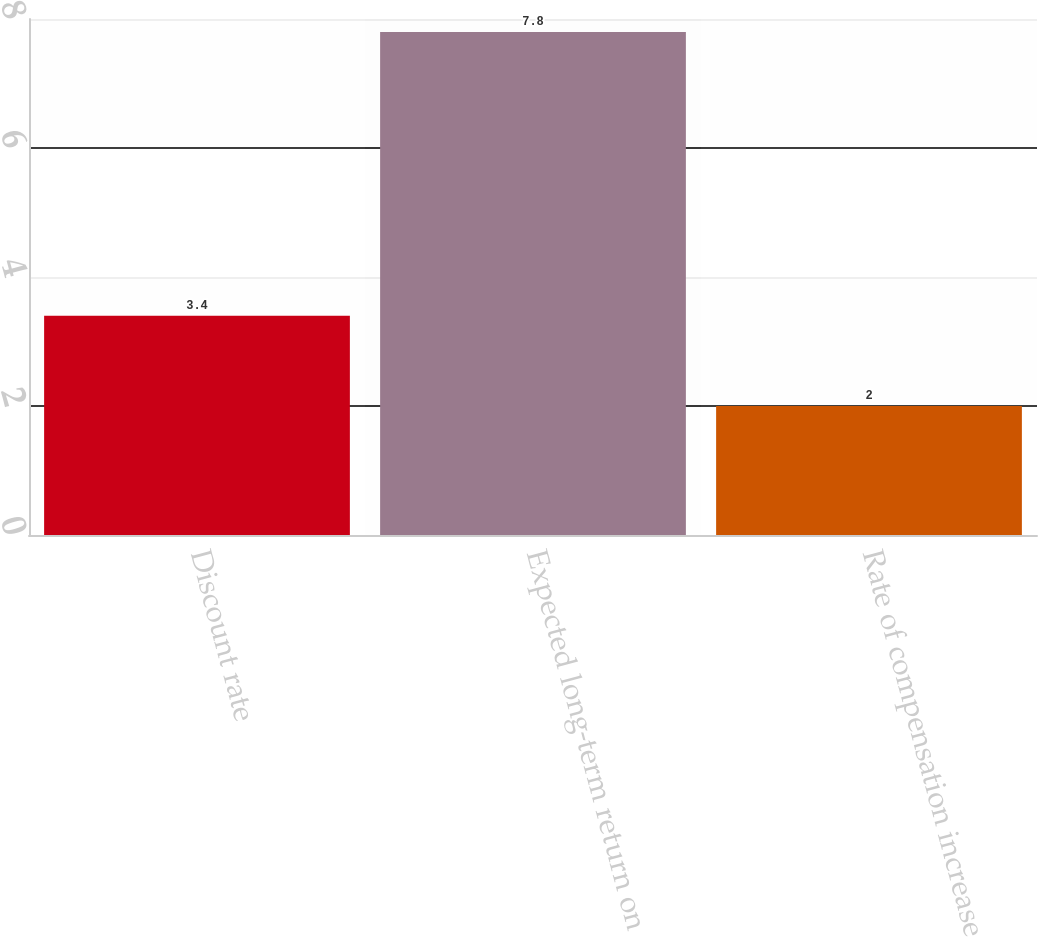Convert chart to OTSL. <chart><loc_0><loc_0><loc_500><loc_500><bar_chart><fcel>Discount rate<fcel>Expected long-term return on<fcel>Rate of compensation increase<nl><fcel>3.4<fcel>7.8<fcel>2<nl></chart> 